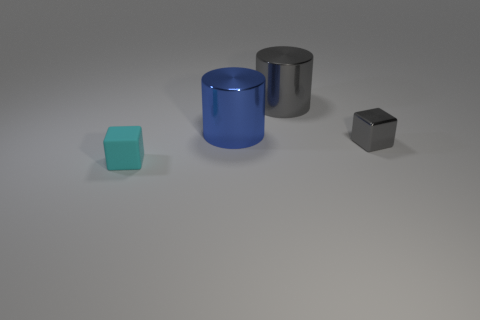Add 2 large red blocks. How many objects exist? 6 Subtract all blue cylinders. How many cylinders are left? 1 Add 3 gray objects. How many gray objects exist? 5 Subtract 0 blue balls. How many objects are left? 4 Subtract all red cubes. Subtract all yellow cylinders. How many cubes are left? 2 Subtract all yellow balls. How many red cubes are left? 0 Subtract all tiny matte objects. Subtract all large cylinders. How many objects are left? 1 Add 2 blue metallic cylinders. How many blue metallic cylinders are left? 3 